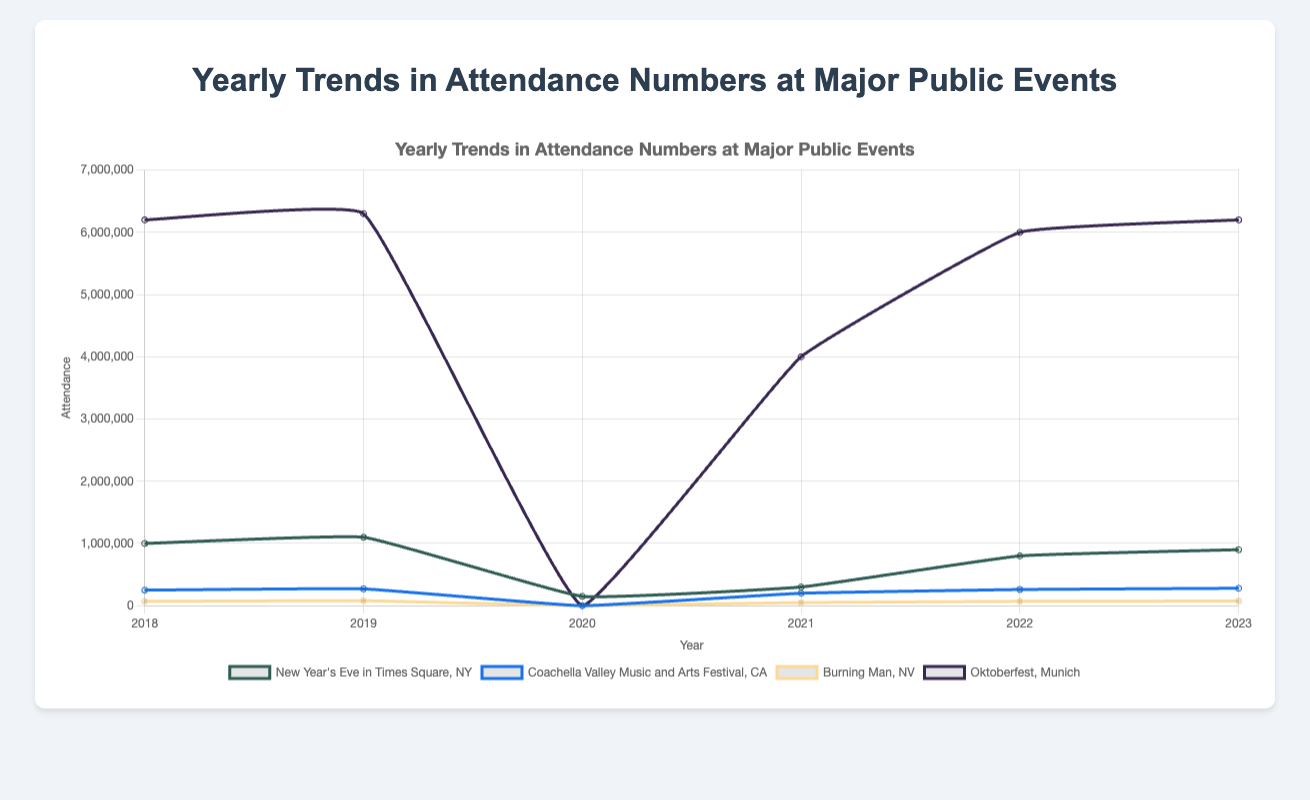What was the highest attendance recorded for the Oktoberfest from 2018 to 2023? Look for the highest point on the line representing Oktoberfest, it peaks at 6,300,000 in 2019, maintaining high values around this range in subsequent years.
Answer: 6,300,000 How did the attendance for New Year's Eve in Times Square change between 2018 and 2023? Observe the line for New Year's Eve event from 2018 to 2023. It starts at 1,000,000 in 2018, peaks in 2019, dips drastically in 2020, slightly recovers in 2021, and rises again by 2023.
Answer: Increased overall with fluctuations Which event had the lowest attendance in the year 2020? Check the lines for all events in 2020, note that multiple events, including Coachella, Burning Man, and Oktoberfest, have attendance of 0 due to pandemic cancellations.
Answer: Coachella, Burning Man, and Oktoberfest Compare the attendance trend for Burning Man and Coachella from 2018 to 2023. Compare the lines representing Burning Man and Coachella. Both show drops to 0 in 2020, but Burning Man has a smaller and later recovery while Coachella shows a consistent increase in attendance post-2020.
Answer: Burning Man has a smaller recovery, Coachella more consistent increase Which season saw the highest peak in attendance throughout these years? Check the peaks for each season’s representative line, the Autumn season’s Oktoberfest repeatedly shows the highest attendance near 6,300,000.
Answer: Autumn (Oktoberfest) How did the attendance for Burning Man in 2019 compare to its attendance in 2021? Refer to the line for Burning Man in years 2019 and 2021 and calculate the difference (80,000 in 2019 and 50,000 in 2021).
Answer: 30,000 lower in 2021 What was the total attendance for New Year's Eve in Times Square across all years? Add the attendance numbers for New Year's Eve in Times Square from 2018 to 2023: (1,000,000 + 1,100,000 + 150,000 + 300,000 + 800,000 + 900,000).
Answer: 4,250,000 Compare the recovery rates of attendance for Coachella and Oktoberfest post-2020. Examine the increase in attendance for Coachella and Oktoberfest after 2020; Coachella shows a steady increase from 0 to 280,000 while Oktoberfest recovers more significantly each year.
Answer: Oktoberfest has a larger recovery rate 